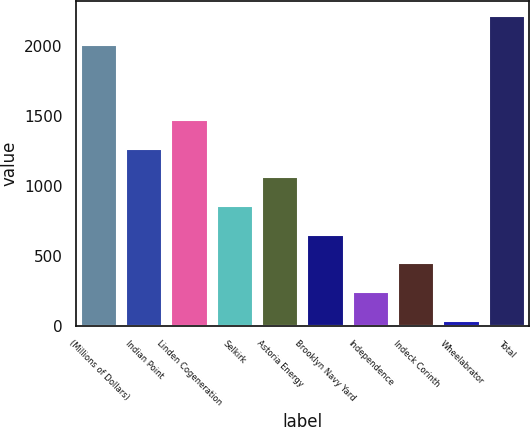<chart> <loc_0><loc_0><loc_500><loc_500><bar_chart><fcel>(Millions of Dollars)<fcel>Indian Point<fcel>Linden Cogeneration<fcel>Selkirk<fcel>Astoria Energy<fcel>Brooklyn Navy Yard<fcel>Independence<fcel>Indeck Corinth<fcel>Wheelabrator<fcel>Total<nl><fcel>2008<fcel>1264.4<fcel>1469.3<fcel>854.6<fcel>1059.5<fcel>649.7<fcel>239.9<fcel>444.8<fcel>35<fcel>2212.9<nl></chart> 